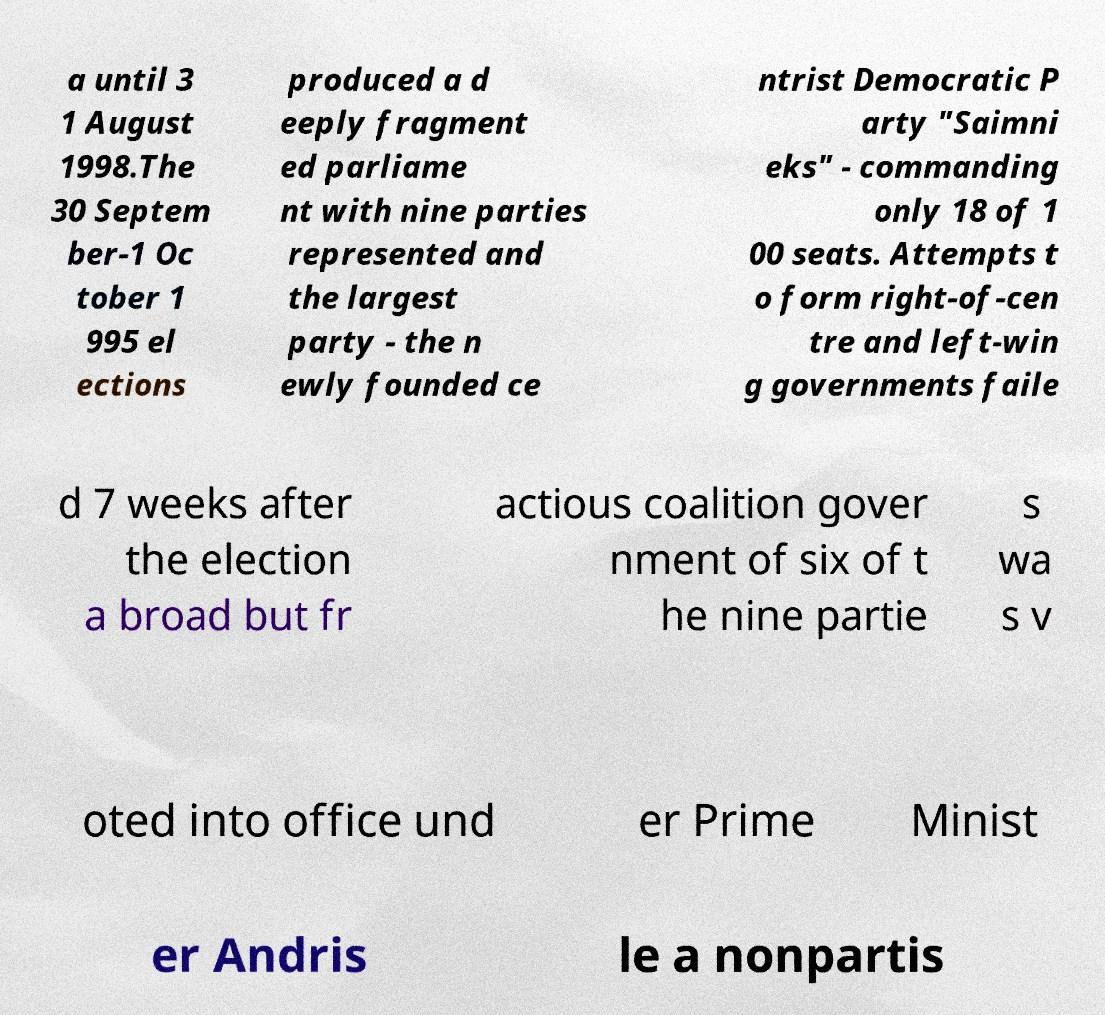There's text embedded in this image that I need extracted. Can you transcribe it verbatim? a until 3 1 August 1998.The 30 Septem ber-1 Oc tober 1 995 el ections produced a d eeply fragment ed parliame nt with nine parties represented and the largest party - the n ewly founded ce ntrist Democratic P arty "Saimni eks" - commanding only 18 of 1 00 seats. Attempts t o form right-of-cen tre and left-win g governments faile d 7 weeks after the election a broad but fr actious coalition gover nment of six of t he nine partie s wa s v oted into office und er Prime Minist er Andris le a nonpartis 